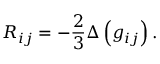Convert formula to latex. <formula><loc_0><loc_0><loc_500><loc_500>R _ { i j } = - { \frac { 2 } { 3 } } \Delta \left ( g _ { i j } \right ) .</formula> 